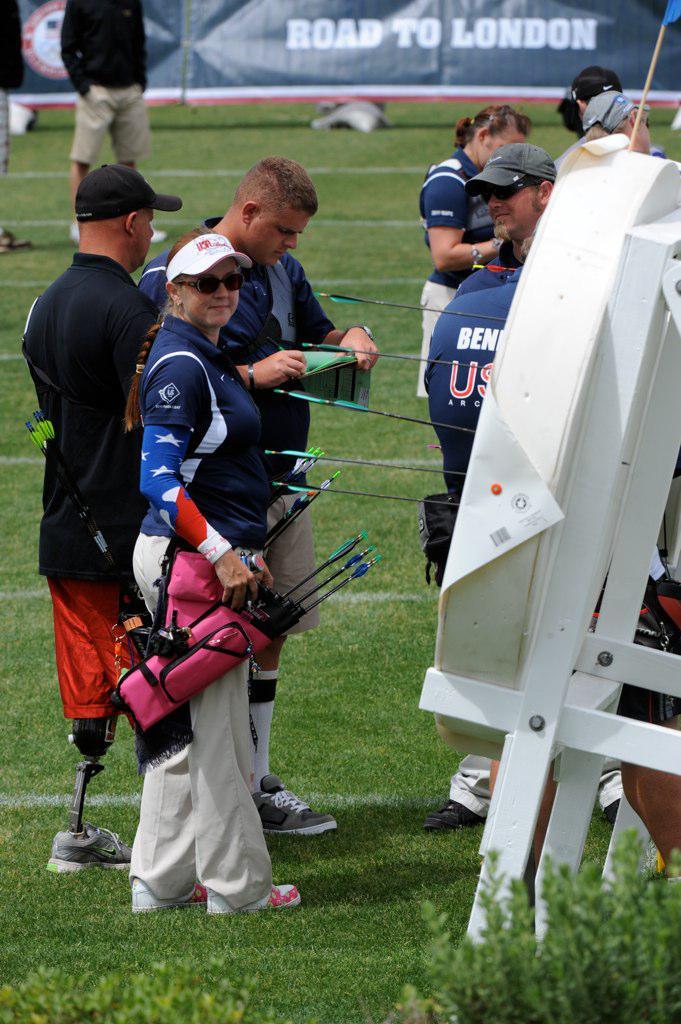What is the road to?
Give a very brief answer. London. 